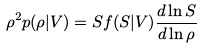<formula> <loc_0><loc_0><loc_500><loc_500>\rho ^ { 2 } p ( \rho | V ) = S f ( S | V ) \frac { d \ln S } { d \ln \rho }</formula> 